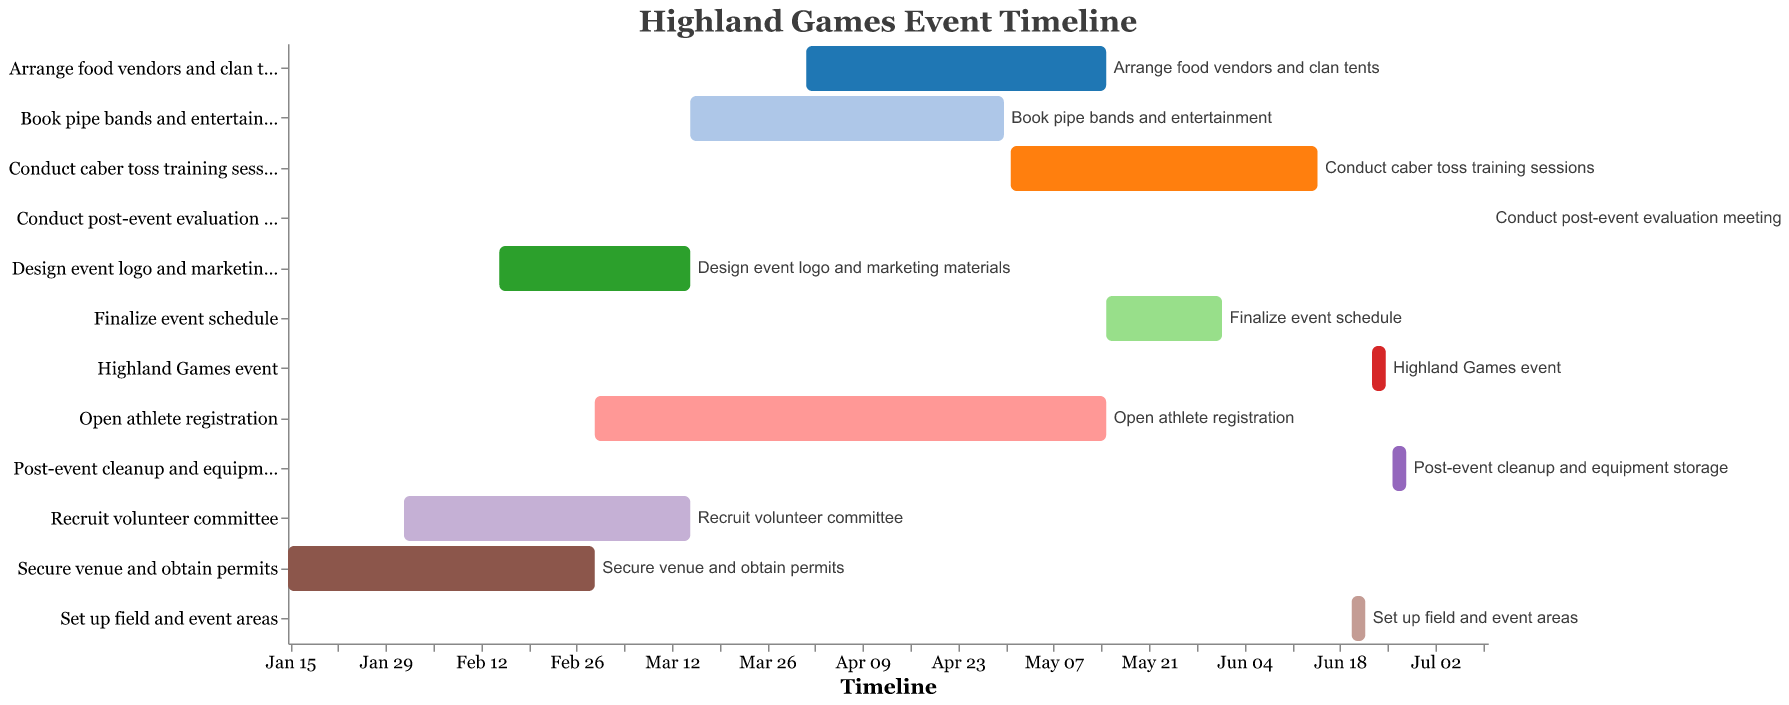What is the title of the Gantt Chart? The title of the Gantt Chart is displayed at the top of the figure and summarizes the content of the chart. Here, the title reads "Highland Games Event Timeline," indicating the schedule for organizing and executing a Highland Games event.
Answer: Highland Games Event Timeline How many tasks start on February 15, 2023? The start dates are plotted along the x-axis. We need to look for bars that begin on February 15, 2023. Only "Design event logo and marketing materials" starts on this date.
Answer: 1 Which task has the shortest duration? By comparing the lengths of the bars, we can identify the task with the shortest period between its start and end dates. "Conduct post-event evaluation meeting" has the shortest duration, with just a single day.
Answer: Conduct post-event evaluation meeting Which task ends immediately before "Set up field and event areas" begins? By checking the end dates of all tasks and comparing them to the start date of "Set up field and event areas" (June 20, 2023), we find that "Finalize event schedule" ends on June 1, 2023, which is the closest preceding event.
Answer: Finalize event schedule What tasks overlap with "Recruit volunteer committee"? We need to identify all tasks whose duration overlaps with the period from February 1, 2023, to March 15, 2023. These tasks are "Secure venue and obtain permits," "Design event logo and marketing materials," and "Open athlete registration."
Answer: Secure venue and obtain permits, Design event logo and marketing materials, Open athlete registration During which month do the most tasks take place? To determine this, we count the number of tasks occurring in each month by checking their start and end dates. May 2023 has the most tasks, with four tasks occurring: "Open athlete registration," "Arrange food vendors and clan tents," "Conduct caber toss training sessions," and "Finalize event schedule."
Answer: May What is the total duration of all tasks combined? To find the total duration, we calculate each task's duration (End Date - Start Date) and sum them up. For instance, "Secure venue and obtain permits" runs from January 15, 2023, to March 1, 2023 (45 days). Adding all task durations (45 + 42 + 28 + 75 + 46 + 45 + 45 + 17 + 2 + 3 + 3 + 1) gives a total of 352 days.
Answer: 352 days Which tasks were completed before May 2023? Checking each task's end date and comparing them to May 1, 2023, we find that "Secure venue and obtain permits," "Recruit volunteer committee," "Design event logo and marketing materials," and "Book pipe bands and entertainment" were completed before May 2023.
Answer: Secure venue and obtain permits, Recruit volunteer committee, Design event logo and marketing materials, Book pipe bands and entertainment Which two tasks have the largest time gap between their end and start dates? By calculating the time gaps between consecutive tasks, we find that the largest gap occurs between "Post-event cleanup and equipment storage" (ending June 28, 2023) and "Conduct post-event evaluation meeting" (starting July 10, 2023), resulting in a 12-day gap.
Answer: Post-event cleanup and equipment storage, Conduct post-event evaluation meeting 